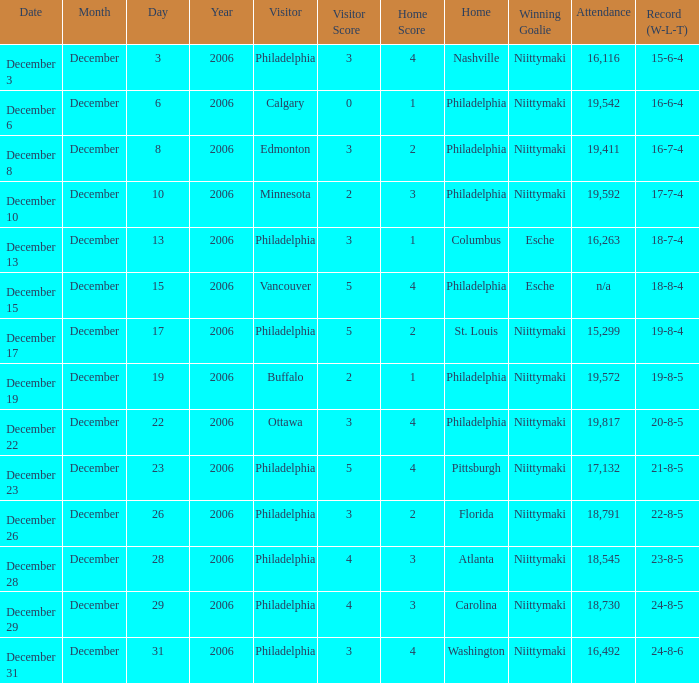With an attendance of 18,545, what was the score at that time? 4 – 3. 